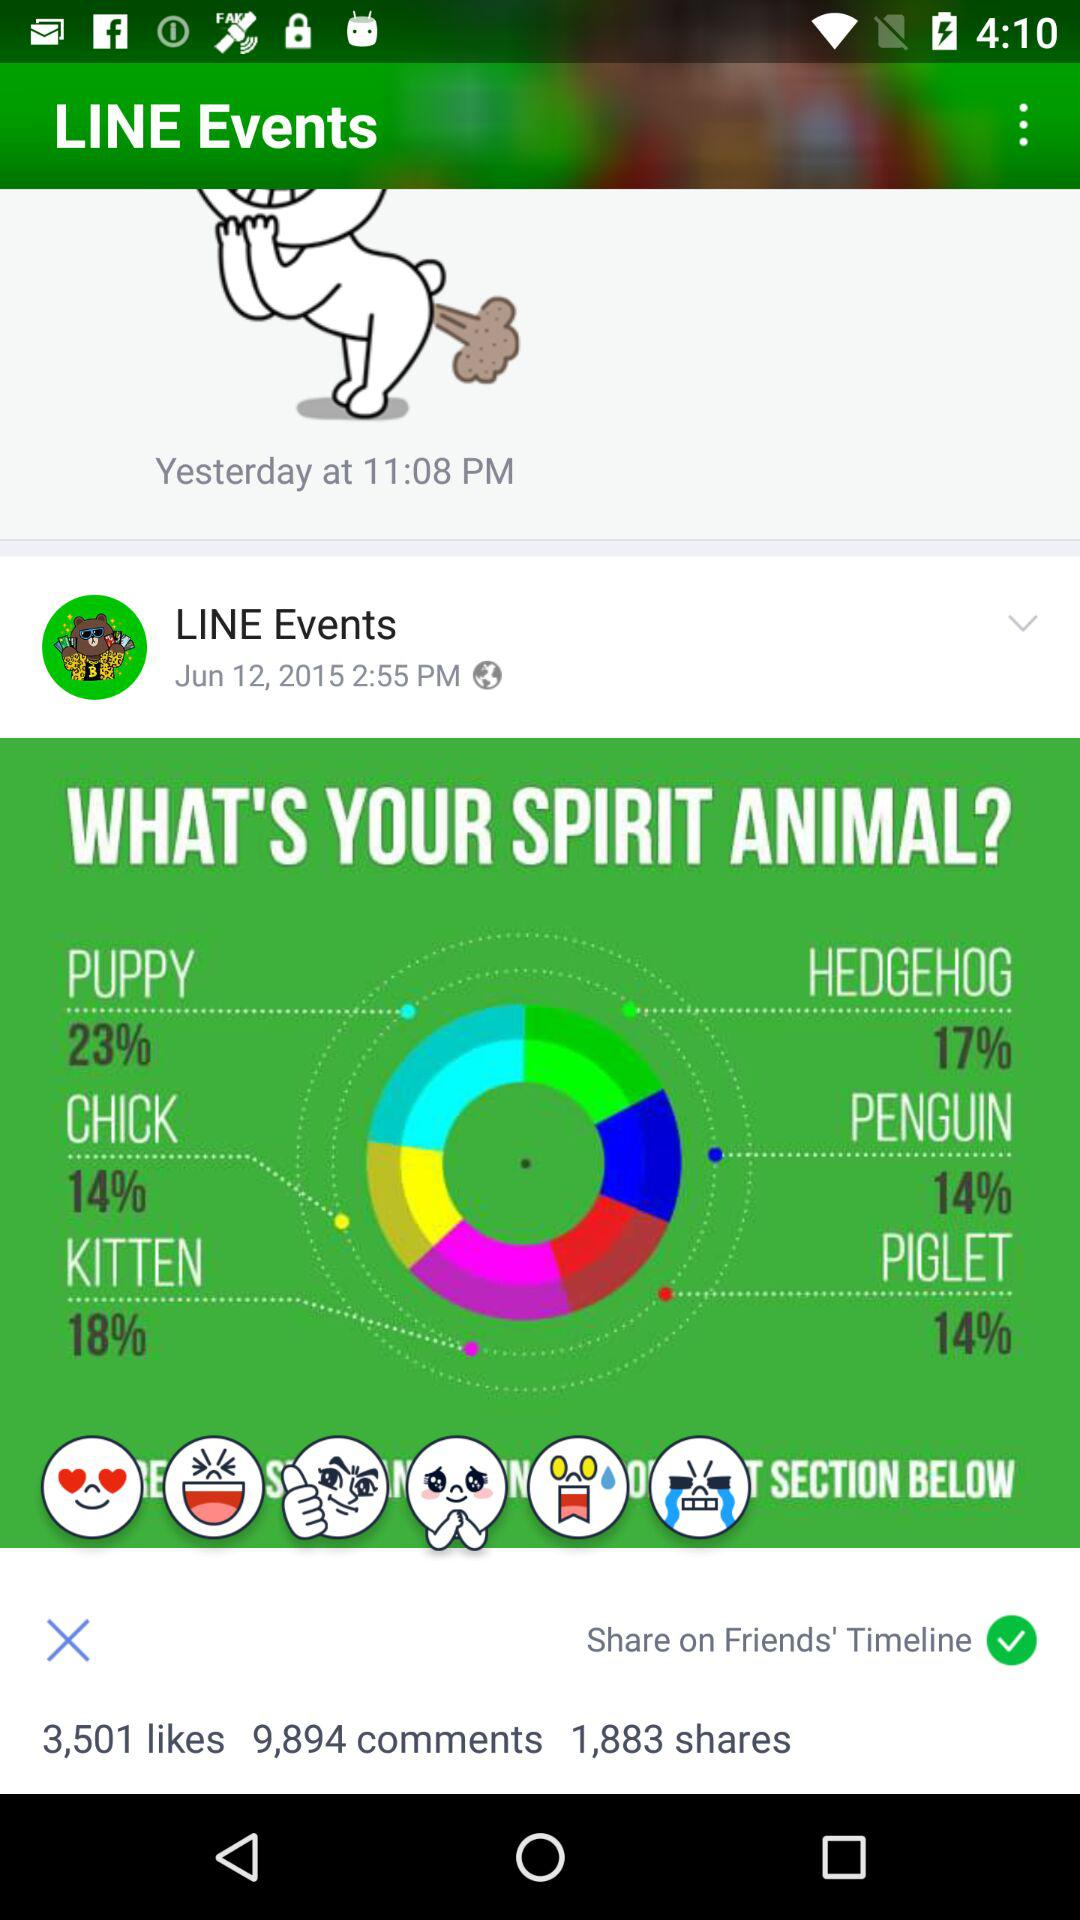How many more comments are there than likes?
Answer the question using a single word or phrase. 6393 